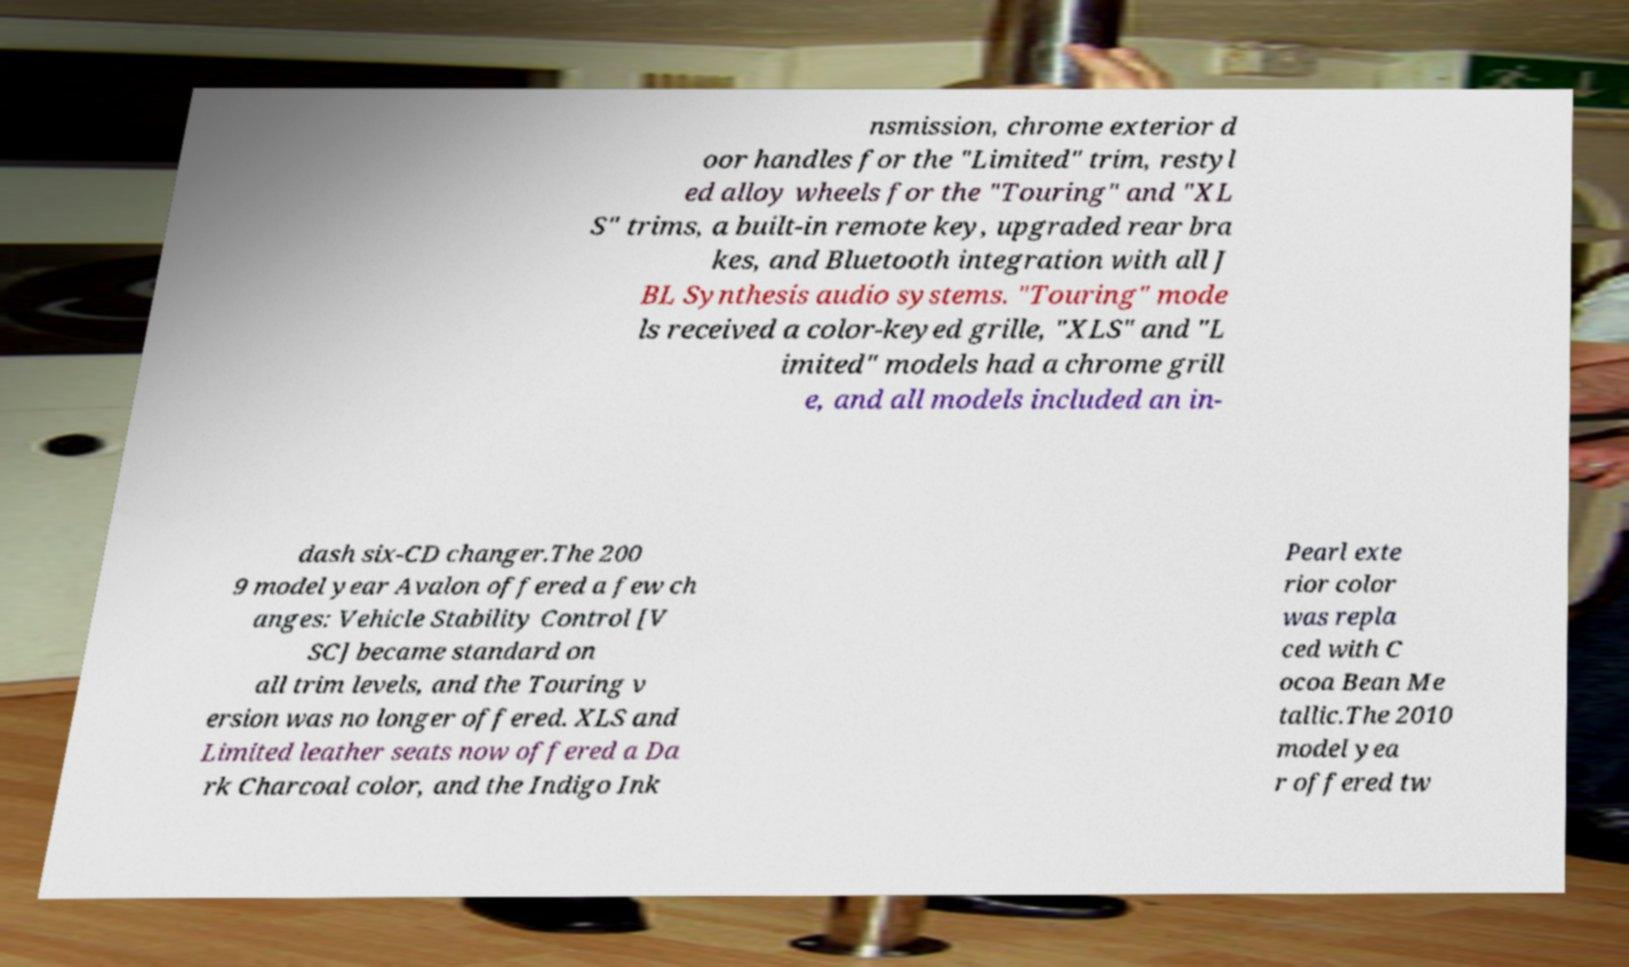Could you extract and type out the text from this image? nsmission, chrome exterior d oor handles for the "Limited" trim, restyl ed alloy wheels for the "Touring" and "XL S" trims, a built-in remote key, upgraded rear bra kes, and Bluetooth integration with all J BL Synthesis audio systems. "Touring" mode ls received a color-keyed grille, "XLS" and "L imited" models had a chrome grill e, and all models included an in- dash six-CD changer.The 200 9 model year Avalon offered a few ch anges: Vehicle Stability Control [V SC] became standard on all trim levels, and the Touring v ersion was no longer offered. XLS and Limited leather seats now offered a Da rk Charcoal color, and the Indigo Ink Pearl exte rior color was repla ced with C ocoa Bean Me tallic.The 2010 model yea r offered tw 